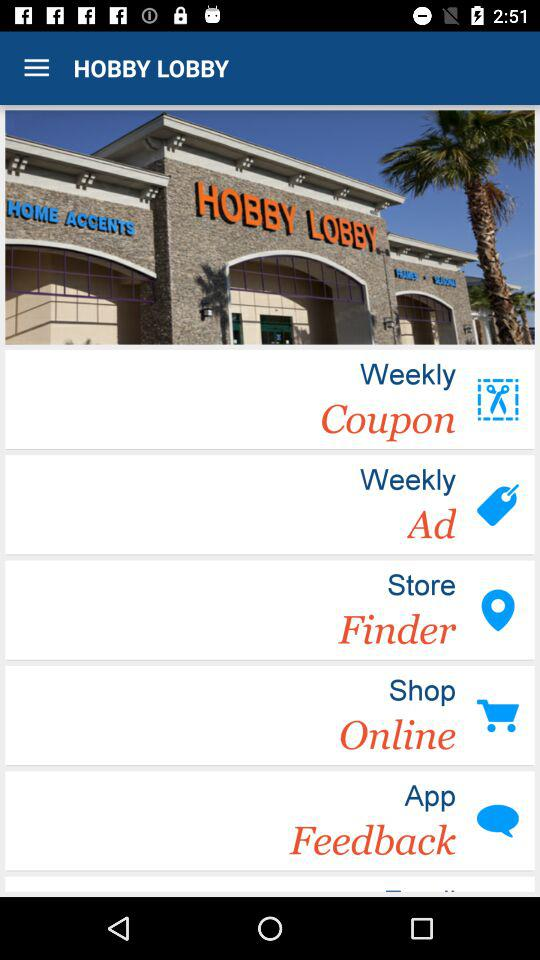What is the name of the application? The name of the application is Hobby Lobby. 